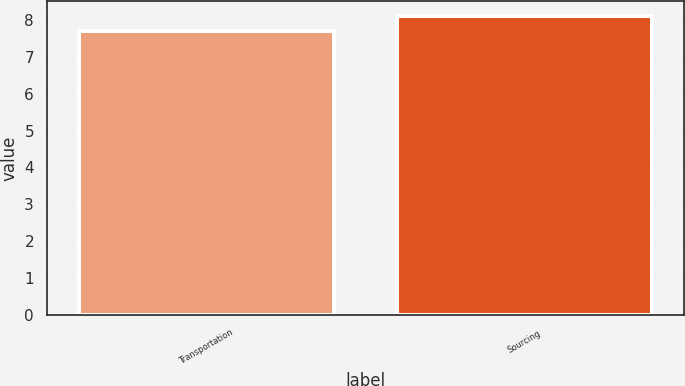Convert chart to OTSL. <chart><loc_0><loc_0><loc_500><loc_500><bar_chart><fcel>Transportation<fcel>Sourcing<nl><fcel>7.7<fcel>8.1<nl></chart> 